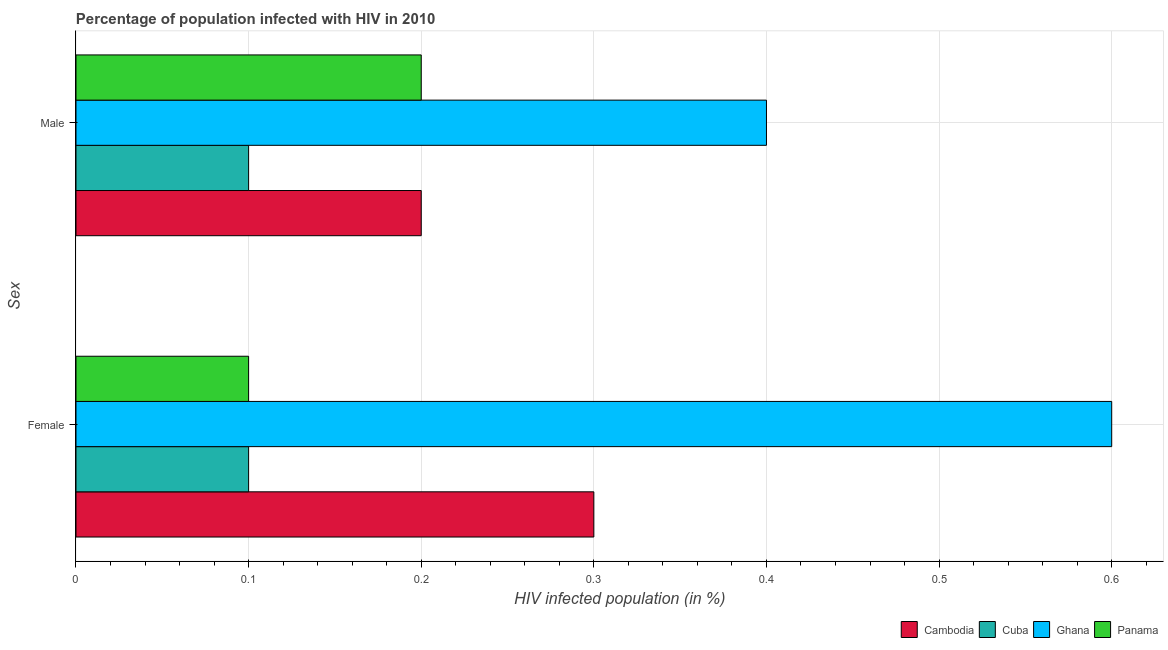Are the number of bars on each tick of the Y-axis equal?
Your answer should be compact. Yes. How many bars are there on the 1st tick from the top?
Ensure brevity in your answer.  4. How many bars are there on the 1st tick from the bottom?
Your answer should be very brief. 4. Across all countries, what is the maximum percentage of males who are infected with hiv?
Offer a very short reply. 0.4. In which country was the percentage of females who are infected with hiv maximum?
Your answer should be very brief. Ghana. In which country was the percentage of females who are infected with hiv minimum?
Offer a very short reply. Cuba. What is the total percentage of females who are infected with hiv in the graph?
Keep it short and to the point. 1.1. What is the difference between the percentage of males who are infected with hiv in Cuba and that in Panama?
Offer a very short reply. -0.1. What is the difference between the percentage of males who are infected with hiv in Cambodia and the percentage of females who are infected with hiv in Cuba?
Your answer should be compact. 0.1. What is the average percentage of females who are infected with hiv per country?
Offer a terse response. 0.28. What is the difference between the percentage of males who are infected with hiv and percentage of females who are infected with hiv in Ghana?
Keep it short and to the point. -0.2. In how many countries, is the percentage of females who are infected with hiv greater than the average percentage of females who are infected with hiv taken over all countries?
Give a very brief answer. 2. What does the 2nd bar from the top in Male represents?
Make the answer very short. Ghana. What does the 3rd bar from the bottom in Female represents?
Provide a succinct answer. Ghana. Does the graph contain any zero values?
Your response must be concise. No. Does the graph contain grids?
Offer a terse response. Yes. Where does the legend appear in the graph?
Give a very brief answer. Bottom right. How many legend labels are there?
Your answer should be compact. 4. How are the legend labels stacked?
Ensure brevity in your answer.  Horizontal. What is the title of the graph?
Keep it short and to the point. Percentage of population infected with HIV in 2010. Does "Romania" appear as one of the legend labels in the graph?
Provide a succinct answer. No. What is the label or title of the X-axis?
Offer a very short reply. HIV infected population (in %). What is the label or title of the Y-axis?
Make the answer very short. Sex. What is the HIV infected population (in %) in Cambodia in Male?
Your answer should be compact. 0.2. Across all Sex, what is the maximum HIV infected population (in %) in Cambodia?
Your answer should be very brief. 0.3. Across all Sex, what is the maximum HIV infected population (in %) of Cuba?
Provide a succinct answer. 0.1. Across all Sex, what is the maximum HIV infected population (in %) of Ghana?
Provide a short and direct response. 0.6. Across all Sex, what is the maximum HIV infected population (in %) in Panama?
Give a very brief answer. 0.2. Across all Sex, what is the minimum HIV infected population (in %) of Cuba?
Your answer should be very brief. 0.1. What is the total HIV infected population (in %) in Cambodia in the graph?
Your answer should be compact. 0.5. What is the total HIV infected population (in %) of Panama in the graph?
Provide a succinct answer. 0.3. What is the difference between the HIV infected population (in %) in Cambodia in Female and that in Male?
Provide a succinct answer. 0.1. What is the difference between the HIV infected population (in %) of Ghana in Female and that in Male?
Your answer should be compact. 0.2. What is the difference between the HIV infected population (in %) in Cambodia in Female and the HIV infected population (in %) in Ghana in Male?
Keep it short and to the point. -0.1. What is the average HIV infected population (in %) in Panama per Sex?
Provide a succinct answer. 0.15. What is the difference between the HIV infected population (in %) in Ghana and HIV infected population (in %) in Panama in Female?
Your answer should be compact. 0.5. What is the difference between the HIV infected population (in %) in Cambodia and HIV infected population (in %) in Ghana in Male?
Offer a very short reply. -0.2. What is the difference between the HIV infected population (in %) in Cambodia and HIV infected population (in %) in Panama in Male?
Ensure brevity in your answer.  0. What is the difference between the HIV infected population (in %) of Ghana and HIV infected population (in %) of Panama in Male?
Provide a short and direct response. 0.2. What is the ratio of the HIV infected population (in %) in Cambodia in Female to that in Male?
Provide a succinct answer. 1.5. What is the ratio of the HIV infected population (in %) of Cuba in Female to that in Male?
Provide a short and direct response. 1. What is the ratio of the HIV infected population (in %) of Panama in Female to that in Male?
Offer a terse response. 0.5. What is the difference between the highest and the second highest HIV infected population (in %) of Cambodia?
Your answer should be very brief. 0.1. What is the difference between the highest and the second highest HIV infected population (in %) in Ghana?
Your answer should be very brief. 0.2. What is the difference between the highest and the lowest HIV infected population (in %) in Cambodia?
Provide a succinct answer. 0.1. What is the difference between the highest and the lowest HIV infected population (in %) of Cuba?
Your response must be concise. 0. What is the difference between the highest and the lowest HIV infected population (in %) of Panama?
Ensure brevity in your answer.  0.1. 